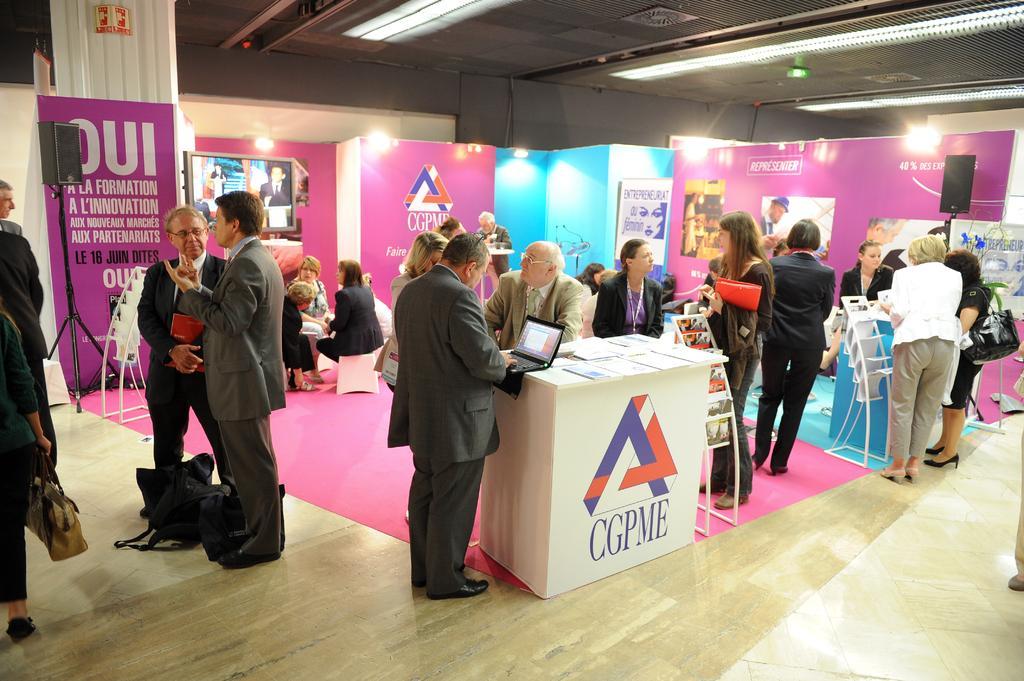How would you summarize this image in a sentence or two? In this image few persons are sitting on the floor and few persons are standing on the floor. There are few bags are on the floor. A person wearing a suit is having a laptop on the table. Beside there are racks having books on it. There is a sound speaker. Behind them there are few stalls. Left side there is a person standing and holding a bag in his hand. 